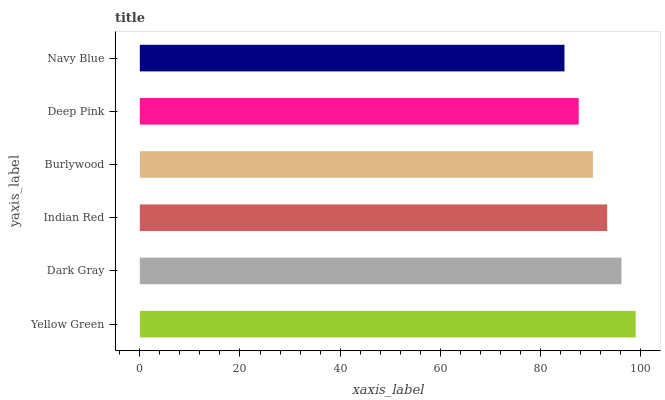Is Navy Blue the minimum?
Answer yes or no. Yes. Is Yellow Green the maximum?
Answer yes or no. Yes. Is Dark Gray the minimum?
Answer yes or no. No. Is Dark Gray the maximum?
Answer yes or no. No. Is Yellow Green greater than Dark Gray?
Answer yes or no. Yes. Is Dark Gray less than Yellow Green?
Answer yes or no. Yes. Is Dark Gray greater than Yellow Green?
Answer yes or no. No. Is Yellow Green less than Dark Gray?
Answer yes or no. No. Is Indian Red the high median?
Answer yes or no. Yes. Is Burlywood the low median?
Answer yes or no. Yes. Is Navy Blue the high median?
Answer yes or no. No. Is Navy Blue the low median?
Answer yes or no. No. 